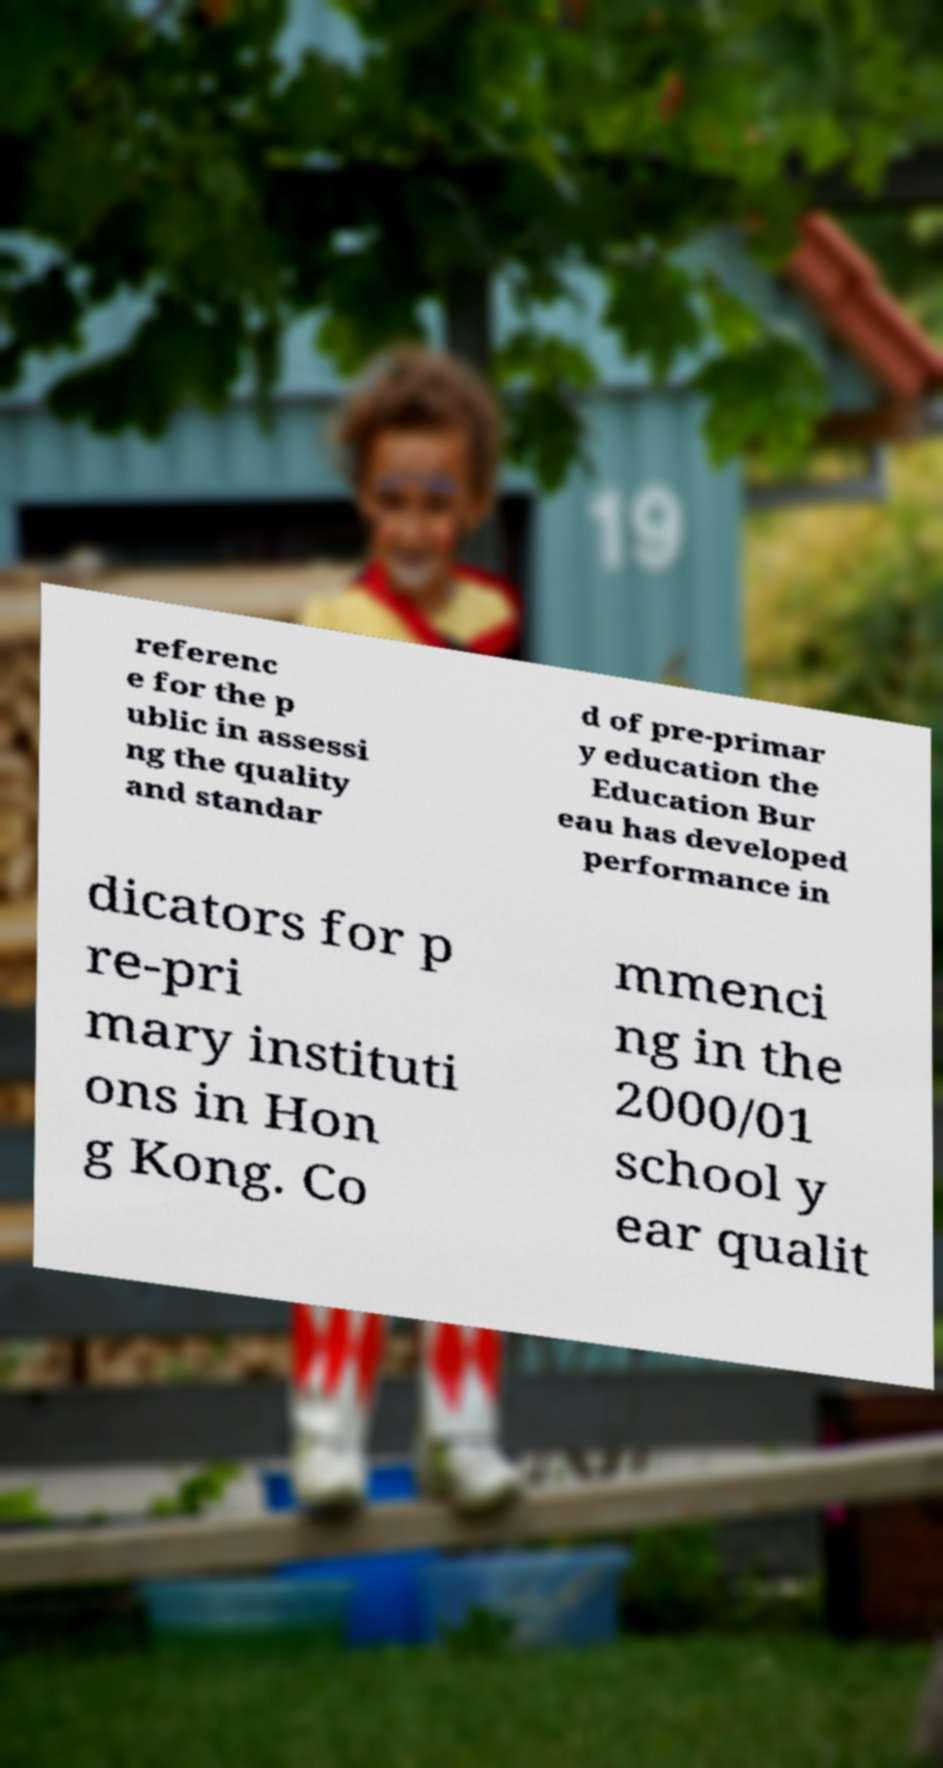Could you assist in decoding the text presented in this image and type it out clearly? referenc e for the p ublic in assessi ng the quality and standar d of pre-primar y education the Education Bur eau has developed performance in dicators for p re-pri mary instituti ons in Hon g Kong. Co mmenci ng in the 2000/01 school y ear qualit 